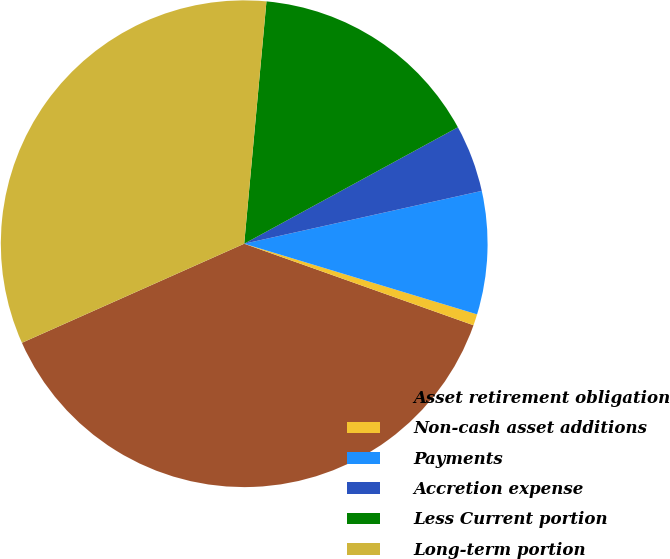<chart> <loc_0><loc_0><loc_500><loc_500><pie_chart><fcel>Asset retirement obligation<fcel>Non-cash asset additions<fcel>Payments<fcel>Accretion expense<fcel>Less Current portion<fcel>Long-term portion<nl><fcel>37.89%<fcel>0.75%<fcel>8.17%<fcel>4.46%<fcel>15.6%<fcel>33.13%<nl></chart> 